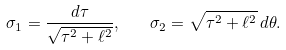<formula> <loc_0><loc_0><loc_500><loc_500>\sigma _ { 1 } = \frac { d \tau } { \sqrt { \tau ^ { 2 } + \ell ^ { 2 } } } , \quad \sigma _ { 2 } = \sqrt { \tau ^ { 2 } + \ell ^ { 2 } } \, d \theta .</formula> 